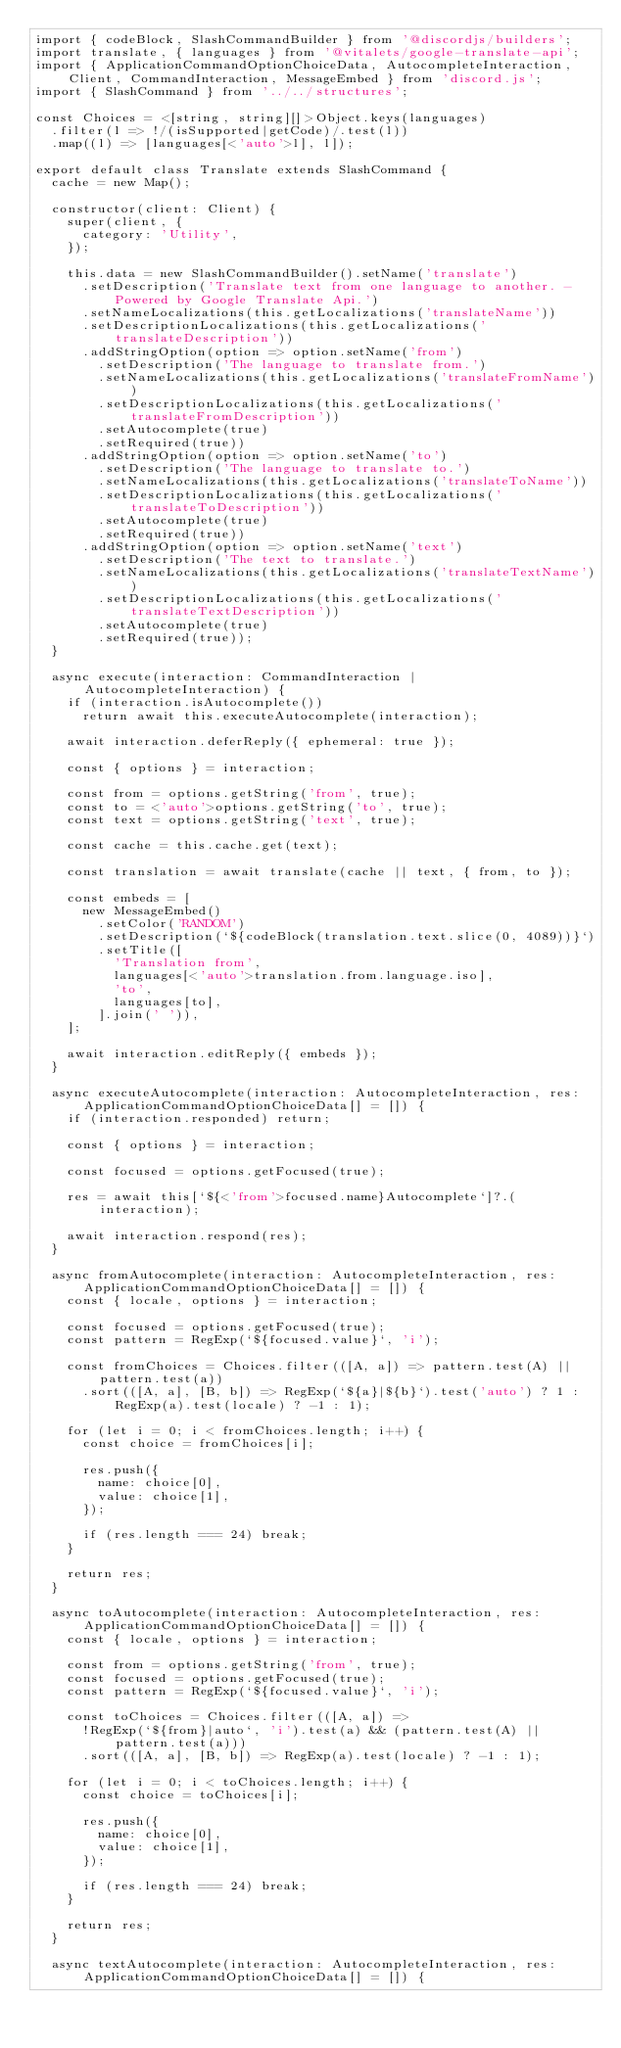Convert code to text. <code><loc_0><loc_0><loc_500><loc_500><_TypeScript_>import { codeBlock, SlashCommandBuilder } from '@discordjs/builders';
import translate, { languages } from '@vitalets/google-translate-api';
import { ApplicationCommandOptionChoiceData, AutocompleteInteraction, Client, CommandInteraction, MessageEmbed } from 'discord.js';
import { SlashCommand } from '../../structures';

const Choices = <[string, string][]>Object.keys(languages)
  .filter(l => !/(isSupported|getCode)/.test(l))
  .map((l) => [languages[<'auto'>l], l]);

export default class Translate extends SlashCommand {
  cache = new Map();

  constructor(client: Client) {
    super(client, {
      category: 'Utility',
    });

    this.data = new SlashCommandBuilder().setName('translate')
      .setDescription('Translate text from one language to another. - Powered by Google Translate Api.')
      .setNameLocalizations(this.getLocalizations('translateName'))
      .setDescriptionLocalizations(this.getLocalizations('translateDescription'))
      .addStringOption(option => option.setName('from')
        .setDescription('The language to translate from.')
        .setNameLocalizations(this.getLocalizations('translateFromName'))
        .setDescriptionLocalizations(this.getLocalizations('translateFromDescription'))
        .setAutocomplete(true)
        .setRequired(true))
      .addStringOption(option => option.setName('to')
        .setDescription('The language to translate to.')
        .setNameLocalizations(this.getLocalizations('translateToName'))
        .setDescriptionLocalizations(this.getLocalizations('translateToDescription'))
        .setAutocomplete(true)
        .setRequired(true))
      .addStringOption(option => option.setName('text')
        .setDescription('The text to translate.')
        .setNameLocalizations(this.getLocalizations('translateTextName'))
        .setDescriptionLocalizations(this.getLocalizations('translateTextDescription'))
        .setAutocomplete(true)
        .setRequired(true));
  }

  async execute(interaction: CommandInteraction | AutocompleteInteraction) {
    if (interaction.isAutocomplete())
      return await this.executeAutocomplete(interaction);

    await interaction.deferReply({ ephemeral: true });

    const { options } = interaction;

    const from = options.getString('from', true);
    const to = <'auto'>options.getString('to', true);
    const text = options.getString('text', true);

    const cache = this.cache.get(text);

    const translation = await translate(cache || text, { from, to });

    const embeds = [
      new MessageEmbed()
        .setColor('RANDOM')
        .setDescription(`${codeBlock(translation.text.slice(0, 4089))}`)
        .setTitle([
          'Translation from',
          languages[<'auto'>translation.from.language.iso],
          'to',
          languages[to],
        ].join(' ')),
    ];

    await interaction.editReply({ embeds });
  }

  async executeAutocomplete(interaction: AutocompleteInteraction, res: ApplicationCommandOptionChoiceData[] = []) {
    if (interaction.responded) return;

    const { options } = interaction;

    const focused = options.getFocused(true);

    res = await this[`${<'from'>focused.name}Autocomplete`]?.(interaction);

    await interaction.respond(res);
  }

  async fromAutocomplete(interaction: AutocompleteInteraction, res: ApplicationCommandOptionChoiceData[] = []) {
    const { locale, options } = interaction;

    const focused = options.getFocused(true);
    const pattern = RegExp(`${focused.value}`, 'i');

    const fromChoices = Choices.filter(([A, a]) => pattern.test(A) || pattern.test(a))
      .sort(([A, a], [B, b]) => RegExp(`${a}|${b}`).test('auto') ? 1 : RegExp(a).test(locale) ? -1 : 1);

    for (let i = 0; i < fromChoices.length; i++) {
      const choice = fromChoices[i];

      res.push({
        name: choice[0],
        value: choice[1],
      });

      if (res.length === 24) break;
    }

    return res;
  }

  async toAutocomplete(interaction: AutocompleteInteraction, res: ApplicationCommandOptionChoiceData[] = []) {
    const { locale, options } = interaction;

    const from = options.getString('from', true);
    const focused = options.getFocused(true);
    const pattern = RegExp(`${focused.value}`, 'i');

    const toChoices = Choices.filter(([A, a]) =>
      !RegExp(`${from}|auto`, 'i').test(a) && (pattern.test(A) || pattern.test(a)))
      .sort(([A, a], [B, b]) => RegExp(a).test(locale) ? -1 : 1);

    for (let i = 0; i < toChoices.length; i++) {
      const choice = toChoices[i];

      res.push({
        name: choice[0],
        value: choice[1],
      });

      if (res.length === 24) break;
    }

    return res;
  }

  async textAutocomplete(interaction: AutocompleteInteraction, res: ApplicationCommandOptionChoiceData[] = []) {</code> 